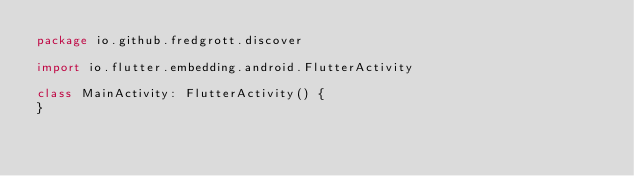<code> <loc_0><loc_0><loc_500><loc_500><_Kotlin_>package io.github.fredgrott.discover

import io.flutter.embedding.android.FlutterActivity

class MainActivity: FlutterActivity() {
}
</code> 